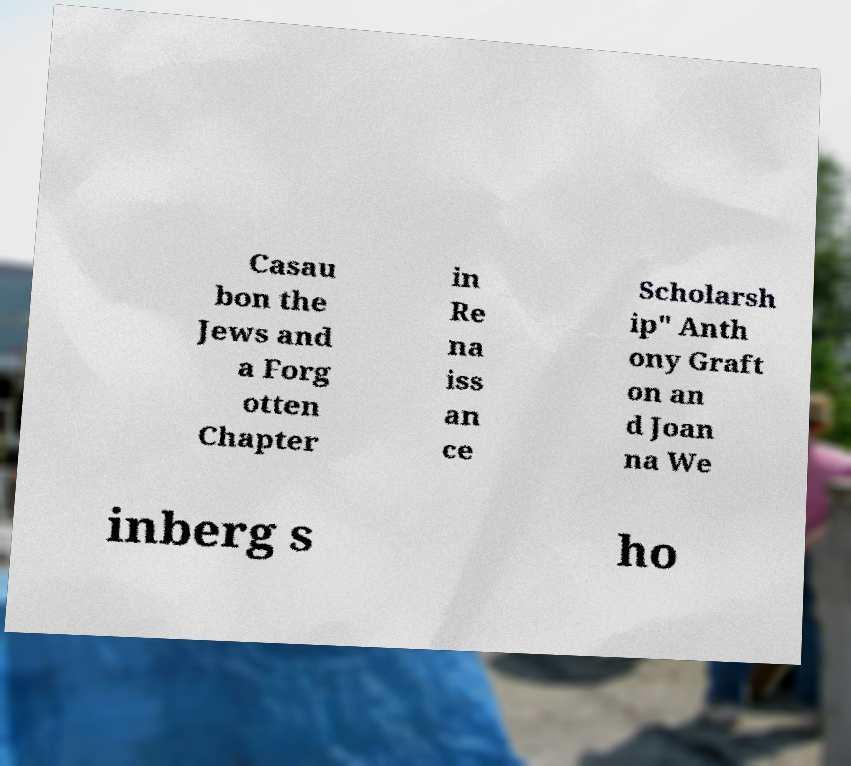Please identify and transcribe the text found in this image. Casau bon the Jews and a Forg otten Chapter in Re na iss an ce Scholarsh ip" Anth ony Graft on an d Joan na We inberg s ho 